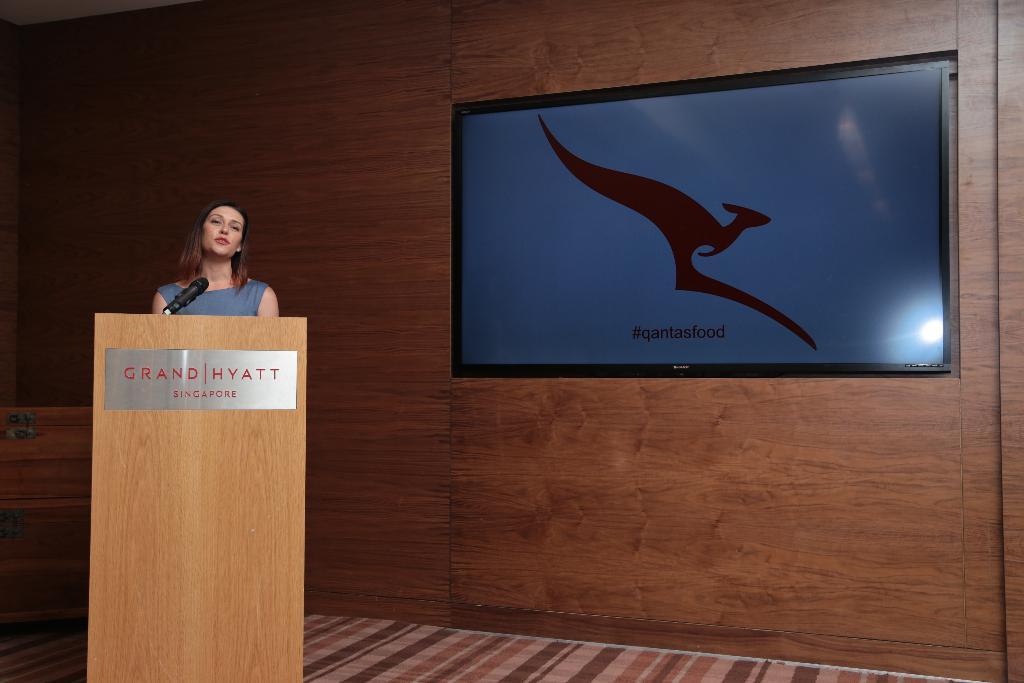In one or two sentences, can you explain what this image depicts? In this picture there is a woman who is standing behind the speech desk, beside her I can see the mic. On the right I can see the screen which is placed on the wooden wall. 